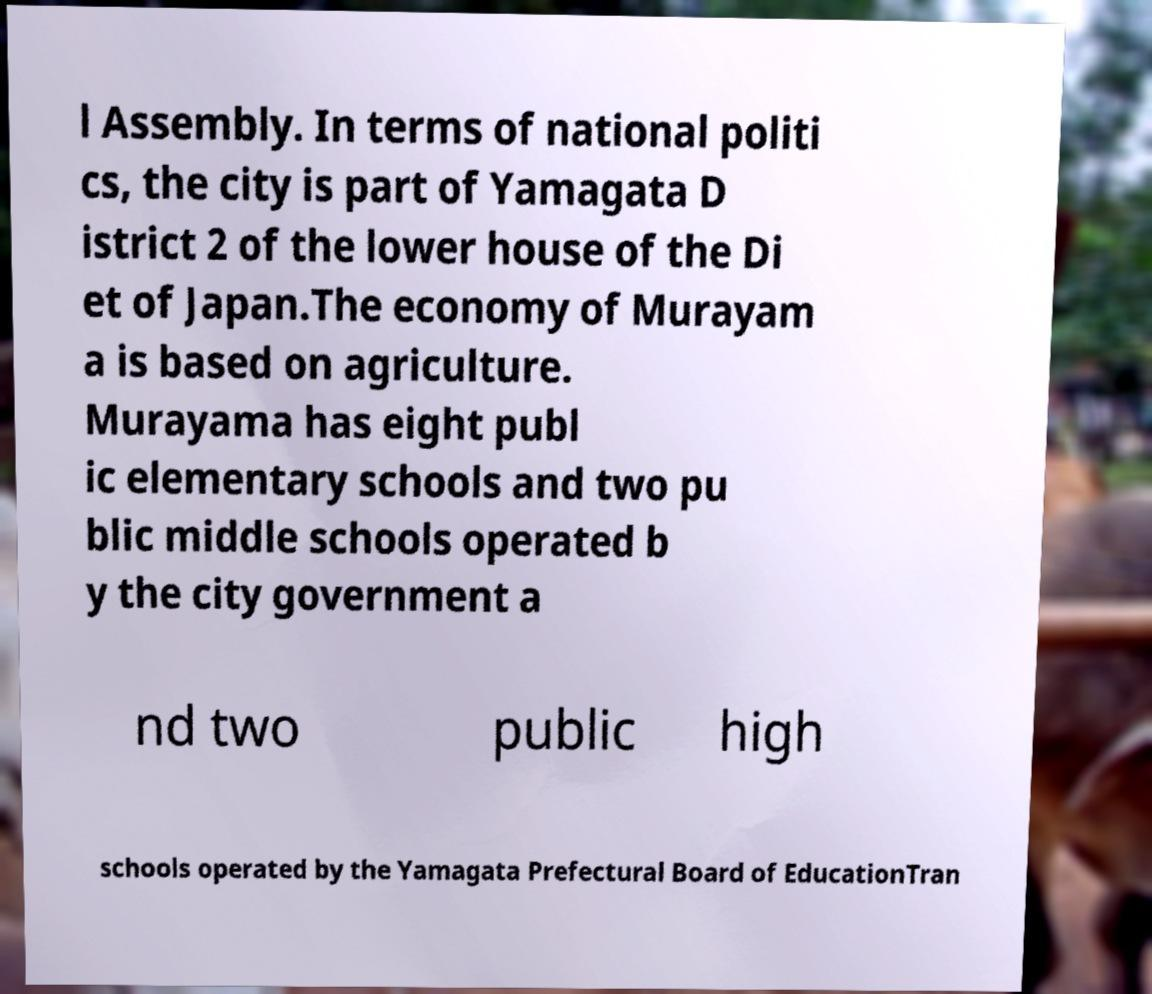Can you read and provide the text displayed in the image?This photo seems to have some interesting text. Can you extract and type it out for me? l Assembly. In terms of national politi cs, the city is part of Yamagata D istrict 2 of the lower house of the Di et of Japan.The economy of Murayam a is based on agriculture. Murayama has eight publ ic elementary schools and two pu blic middle schools operated b y the city government a nd two public high schools operated by the Yamagata Prefectural Board of EducationTran 